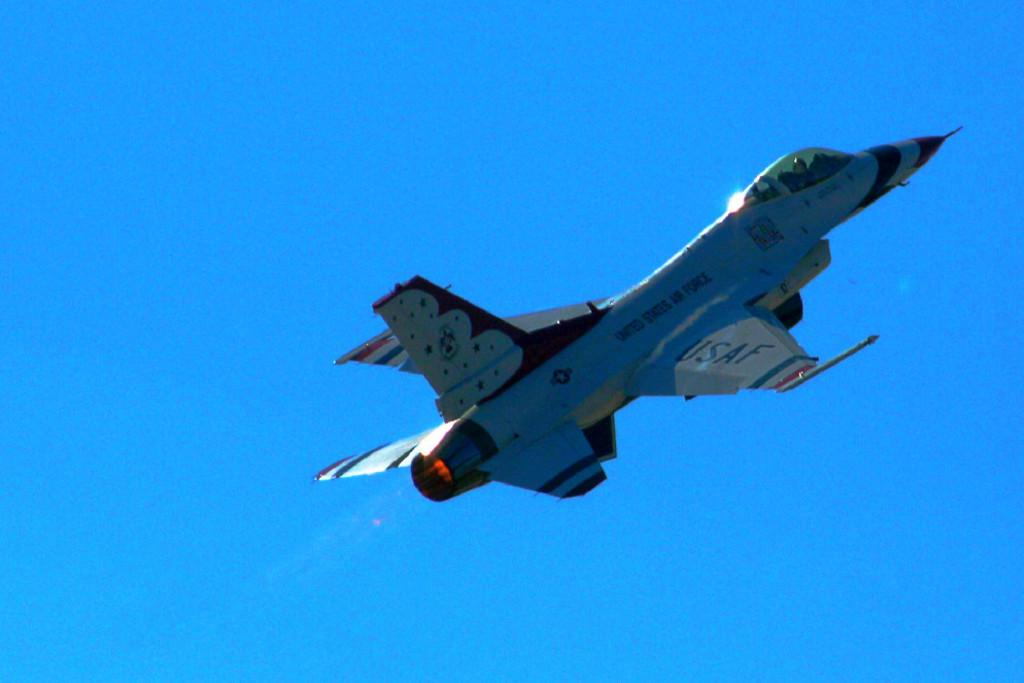<image>
Give a short and clear explanation of the subsequent image. An aircraft for the USAF flies alone in the blue sky. 